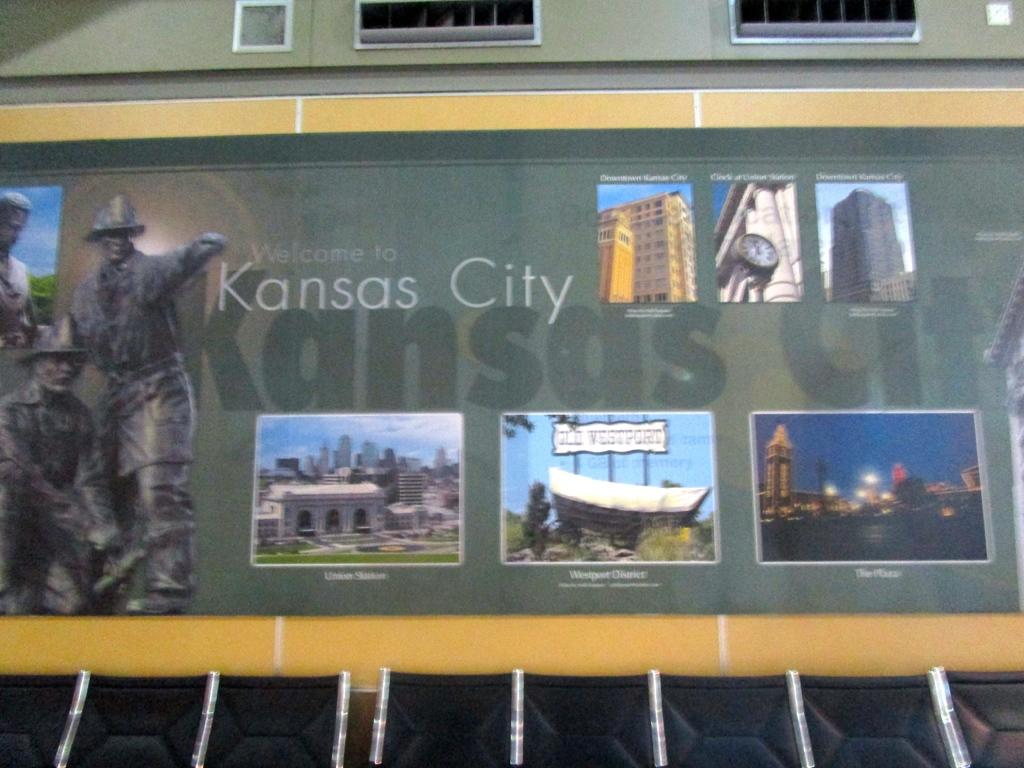<image>
Render a clear and concise summary of the photo. A display on a building commemorating Kansas City's locations. 